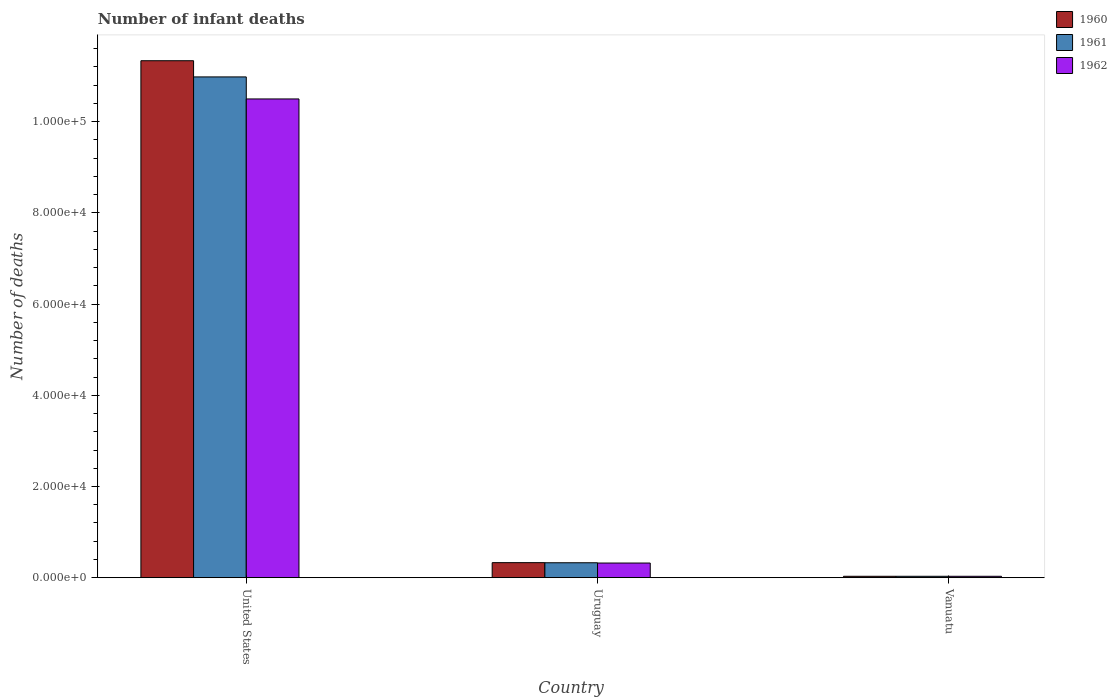How many groups of bars are there?
Your response must be concise. 3. Are the number of bars on each tick of the X-axis equal?
Keep it short and to the point. Yes. What is the label of the 2nd group of bars from the left?
Offer a very short reply. Uruguay. What is the number of infant deaths in 1962 in Vanuatu?
Provide a short and direct response. 311. Across all countries, what is the maximum number of infant deaths in 1960?
Provide a succinct answer. 1.13e+05. Across all countries, what is the minimum number of infant deaths in 1961?
Your answer should be compact. 311. In which country was the number of infant deaths in 1961 maximum?
Keep it short and to the point. United States. In which country was the number of infant deaths in 1960 minimum?
Provide a succinct answer. Vanuatu. What is the total number of infant deaths in 1960 in the graph?
Your answer should be very brief. 1.17e+05. What is the difference between the number of infant deaths in 1962 in United States and that in Vanuatu?
Your response must be concise. 1.05e+05. What is the difference between the number of infant deaths in 1961 in United States and the number of infant deaths in 1960 in Vanuatu?
Your answer should be very brief. 1.09e+05. What is the average number of infant deaths in 1961 per country?
Your response must be concise. 3.78e+04. What is the difference between the number of infant deaths of/in 1961 and number of infant deaths of/in 1960 in United States?
Offer a terse response. -3550. In how many countries, is the number of infant deaths in 1961 greater than 20000?
Your answer should be compact. 1. What is the ratio of the number of infant deaths in 1960 in United States to that in Vanuatu?
Provide a short and direct response. 364.48. Is the number of infant deaths in 1960 in United States less than that in Vanuatu?
Your answer should be very brief. No. Is the difference between the number of infant deaths in 1961 in United States and Uruguay greater than the difference between the number of infant deaths in 1960 in United States and Uruguay?
Your answer should be compact. No. What is the difference between the highest and the second highest number of infant deaths in 1960?
Your response must be concise. 1.10e+05. What is the difference between the highest and the lowest number of infant deaths in 1961?
Your answer should be compact. 1.09e+05. In how many countries, is the number of infant deaths in 1960 greater than the average number of infant deaths in 1960 taken over all countries?
Your answer should be very brief. 1. Is the sum of the number of infant deaths in 1962 in United States and Uruguay greater than the maximum number of infant deaths in 1961 across all countries?
Provide a short and direct response. No. Are all the bars in the graph horizontal?
Your answer should be compact. No. What is the difference between two consecutive major ticks on the Y-axis?
Your answer should be compact. 2.00e+04. Does the graph contain any zero values?
Provide a short and direct response. No. Does the graph contain grids?
Give a very brief answer. No. Where does the legend appear in the graph?
Provide a succinct answer. Top right. How many legend labels are there?
Keep it short and to the point. 3. What is the title of the graph?
Keep it short and to the point. Number of infant deaths. Does "1982" appear as one of the legend labels in the graph?
Give a very brief answer. No. What is the label or title of the X-axis?
Offer a very short reply. Country. What is the label or title of the Y-axis?
Provide a short and direct response. Number of deaths. What is the Number of deaths in 1960 in United States?
Offer a terse response. 1.13e+05. What is the Number of deaths of 1961 in United States?
Make the answer very short. 1.10e+05. What is the Number of deaths of 1962 in United States?
Provide a succinct answer. 1.05e+05. What is the Number of deaths in 1960 in Uruguay?
Provide a succinct answer. 3301. What is the Number of deaths of 1961 in Uruguay?
Offer a very short reply. 3277. What is the Number of deaths of 1962 in Uruguay?
Your answer should be compact. 3216. What is the Number of deaths of 1960 in Vanuatu?
Offer a terse response. 311. What is the Number of deaths of 1961 in Vanuatu?
Keep it short and to the point. 311. What is the Number of deaths in 1962 in Vanuatu?
Ensure brevity in your answer.  311. Across all countries, what is the maximum Number of deaths of 1960?
Keep it short and to the point. 1.13e+05. Across all countries, what is the maximum Number of deaths in 1961?
Make the answer very short. 1.10e+05. Across all countries, what is the maximum Number of deaths in 1962?
Your answer should be compact. 1.05e+05. Across all countries, what is the minimum Number of deaths of 1960?
Provide a succinct answer. 311. Across all countries, what is the minimum Number of deaths of 1961?
Provide a succinct answer. 311. Across all countries, what is the minimum Number of deaths in 1962?
Offer a very short reply. 311. What is the total Number of deaths in 1960 in the graph?
Offer a very short reply. 1.17e+05. What is the total Number of deaths of 1961 in the graph?
Your answer should be compact. 1.13e+05. What is the total Number of deaths of 1962 in the graph?
Your response must be concise. 1.09e+05. What is the difference between the Number of deaths of 1960 in United States and that in Uruguay?
Keep it short and to the point. 1.10e+05. What is the difference between the Number of deaths in 1961 in United States and that in Uruguay?
Provide a short and direct response. 1.07e+05. What is the difference between the Number of deaths in 1962 in United States and that in Uruguay?
Provide a short and direct response. 1.02e+05. What is the difference between the Number of deaths of 1960 in United States and that in Vanuatu?
Give a very brief answer. 1.13e+05. What is the difference between the Number of deaths in 1961 in United States and that in Vanuatu?
Your answer should be very brief. 1.09e+05. What is the difference between the Number of deaths in 1962 in United States and that in Vanuatu?
Provide a short and direct response. 1.05e+05. What is the difference between the Number of deaths in 1960 in Uruguay and that in Vanuatu?
Your response must be concise. 2990. What is the difference between the Number of deaths of 1961 in Uruguay and that in Vanuatu?
Provide a short and direct response. 2966. What is the difference between the Number of deaths in 1962 in Uruguay and that in Vanuatu?
Provide a short and direct response. 2905. What is the difference between the Number of deaths of 1960 in United States and the Number of deaths of 1961 in Uruguay?
Offer a terse response. 1.10e+05. What is the difference between the Number of deaths in 1960 in United States and the Number of deaths in 1962 in Uruguay?
Your response must be concise. 1.10e+05. What is the difference between the Number of deaths in 1961 in United States and the Number of deaths in 1962 in Uruguay?
Provide a short and direct response. 1.07e+05. What is the difference between the Number of deaths of 1960 in United States and the Number of deaths of 1961 in Vanuatu?
Give a very brief answer. 1.13e+05. What is the difference between the Number of deaths of 1960 in United States and the Number of deaths of 1962 in Vanuatu?
Your response must be concise. 1.13e+05. What is the difference between the Number of deaths of 1961 in United States and the Number of deaths of 1962 in Vanuatu?
Offer a very short reply. 1.09e+05. What is the difference between the Number of deaths of 1960 in Uruguay and the Number of deaths of 1961 in Vanuatu?
Provide a succinct answer. 2990. What is the difference between the Number of deaths in 1960 in Uruguay and the Number of deaths in 1962 in Vanuatu?
Give a very brief answer. 2990. What is the difference between the Number of deaths of 1961 in Uruguay and the Number of deaths of 1962 in Vanuatu?
Give a very brief answer. 2966. What is the average Number of deaths of 1960 per country?
Keep it short and to the point. 3.90e+04. What is the average Number of deaths of 1961 per country?
Provide a short and direct response. 3.78e+04. What is the average Number of deaths of 1962 per country?
Ensure brevity in your answer.  3.62e+04. What is the difference between the Number of deaths in 1960 and Number of deaths in 1961 in United States?
Provide a succinct answer. 3550. What is the difference between the Number of deaths in 1960 and Number of deaths in 1962 in United States?
Provide a short and direct response. 8380. What is the difference between the Number of deaths of 1961 and Number of deaths of 1962 in United States?
Provide a succinct answer. 4830. What is the difference between the Number of deaths in 1960 and Number of deaths in 1962 in Uruguay?
Your answer should be compact. 85. What is the difference between the Number of deaths in 1960 and Number of deaths in 1961 in Vanuatu?
Your answer should be compact. 0. What is the difference between the Number of deaths in 1961 and Number of deaths in 1962 in Vanuatu?
Keep it short and to the point. 0. What is the ratio of the Number of deaths of 1960 in United States to that in Uruguay?
Provide a short and direct response. 34.34. What is the ratio of the Number of deaths in 1961 in United States to that in Uruguay?
Provide a short and direct response. 33.51. What is the ratio of the Number of deaths in 1962 in United States to that in Uruguay?
Offer a terse response. 32.64. What is the ratio of the Number of deaths in 1960 in United States to that in Vanuatu?
Give a very brief answer. 364.48. What is the ratio of the Number of deaths of 1961 in United States to that in Vanuatu?
Your response must be concise. 353.07. What is the ratio of the Number of deaths of 1962 in United States to that in Vanuatu?
Keep it short and to the point. 337.54. What is the ratio of the Number of deaths of 1960 in Uruguay to that in Vanuatu?
Your response must be concise. 10.61. What is the ratio of the Number of deaths in 1961 in Uruguay to that in Vanuatu?
Your answer should be compact. 10.54. What is the ratio of the Number of deaths in 1962 in Uruguay to that in Vanuatu?
Offer a terse response. 10.34. What is the difference between the highest and the second highest Number of deaths in 1960?
Offer a terse response. 1.10e+05. What is the difference between the highest and the second highest Number of deaths in 1961?
Provide a succinct answer. 1.07e+05. What is the difference between the highest and the second highest Number of deaths of 1962?
Your response must be concise. 1.02e+05. What is the difference between the highest and the lowest Number of deaths of 1960?
Your answer should be compact. 1.13e+05. What is the difference between the highest and the lowest Number of deaths of 1961?
Offer a very short reply. 1.09e+05. What is the difference between the highest and the lowest Number of deaths of 1962?
Your answer should be compact. 1.05e+05. 